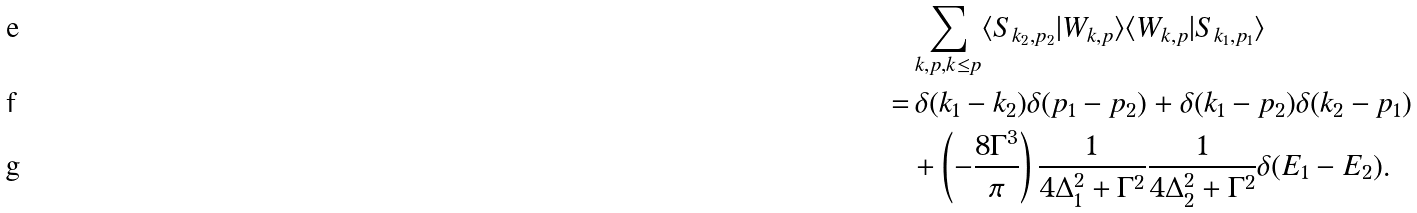Convert formula to latex. <formula><loc_0><loc_0><loc_500><loc_500>& \sum _ { k , p , k \leq p } \langle S _ { k _ { 2 } , p _ { 2 } } | W _ { k , p } \rangle \langle W _ { k , p } | S _ { k _ { 1 } , p _ { 1 } } \rangle \\ = & \, \delta ( k _ { 1 } - k _ { 2 } ) \delta ( p _ { 1 } - p _ { 2 } ) + \delta ( k _ { 1 } - p _ { 2 } ) \delta ( k _ { 2 } - p _ { 1 } ) \\ & + \left ( - \frac { 8 \Gamma ^ { 3 } } { \pi } \right ) \frac { 1 } { 4 \Delta _ { 1 } ^ { 2 } + \Gamma ^ { 2 } } \frac { 1 } { 4 \Delta _ { 2 } ^ { 2 } + \Gamma ^ { 2 } } \delta ( E _ { 1 } - E _ { 2 } ) .</formula> 